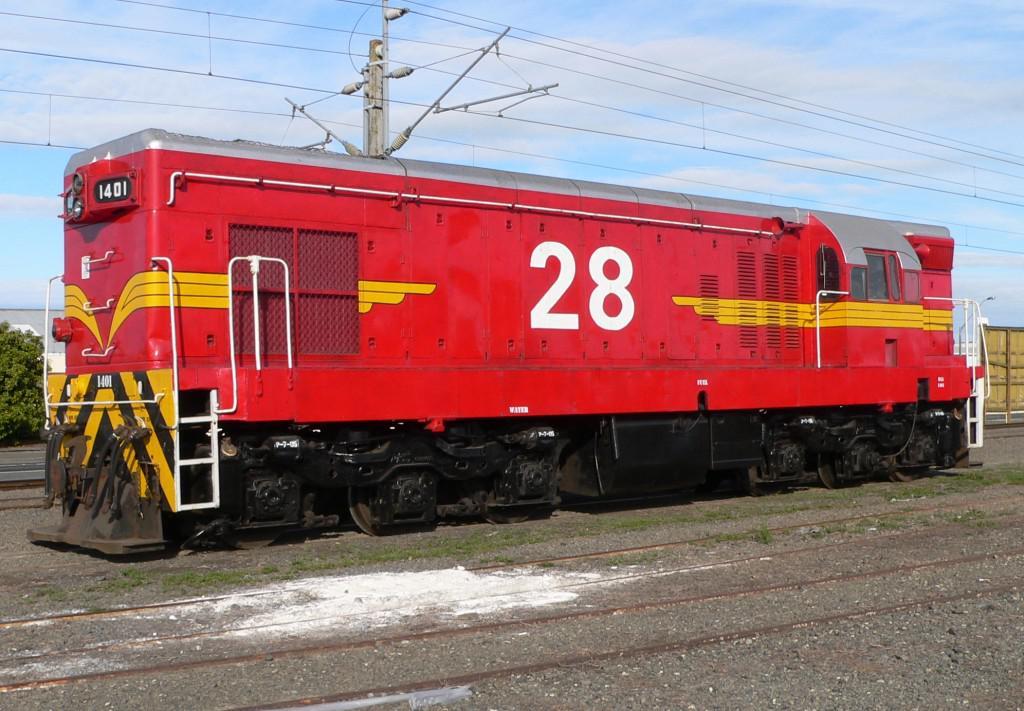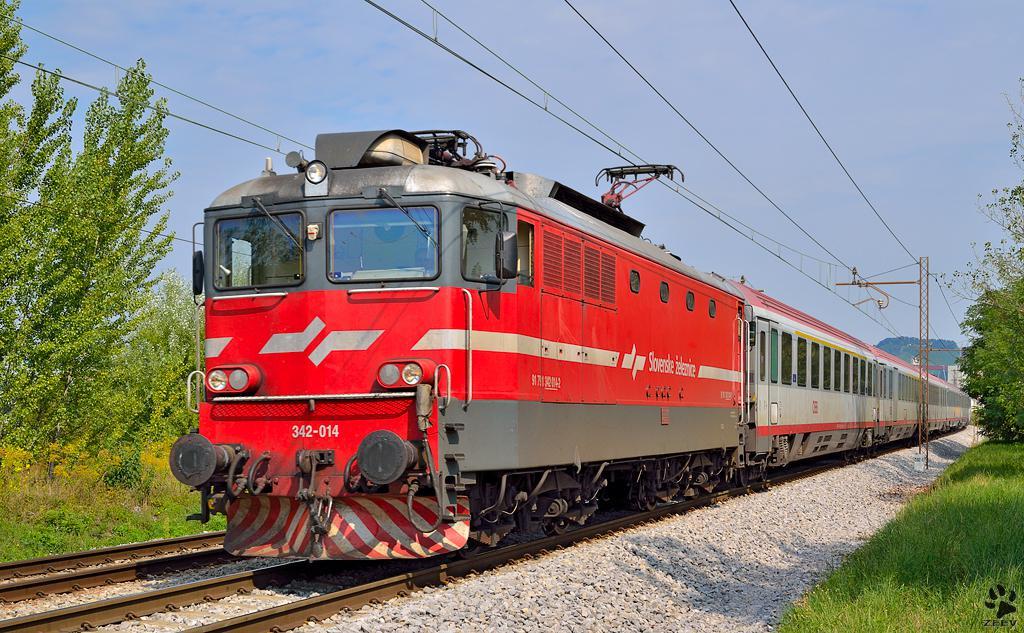The first image is the image on the left, the second image is the image on the right. Analyze the images presented: Is the assertion "There are two trains in the image on the right." valid? Answer yes or no. No. The first image is the image on the left, the second image is the image on the right. Analyze the images presented: Is the assertion "Exactly two trains in total are shown, with all trains pointing rightward." valid? Answer yes or no. No. 